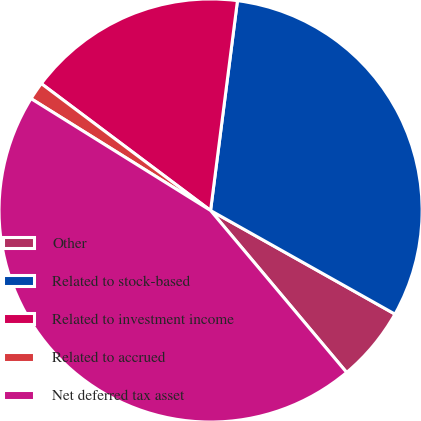Convert chart to OTSL. <chart><loc_0><loc_0><loc_500><loc_500><pie_chart><fcel>Other<fcel>Related to stock-based<fcel>Related to investment income<fcel>Related to accrued<fcel>Net deferred tax asset<nl><fcel>5.73%<fcel>31.12%<fcel>16.79%<fcel>1.37%<fcel>44.99%<nl></chart> 